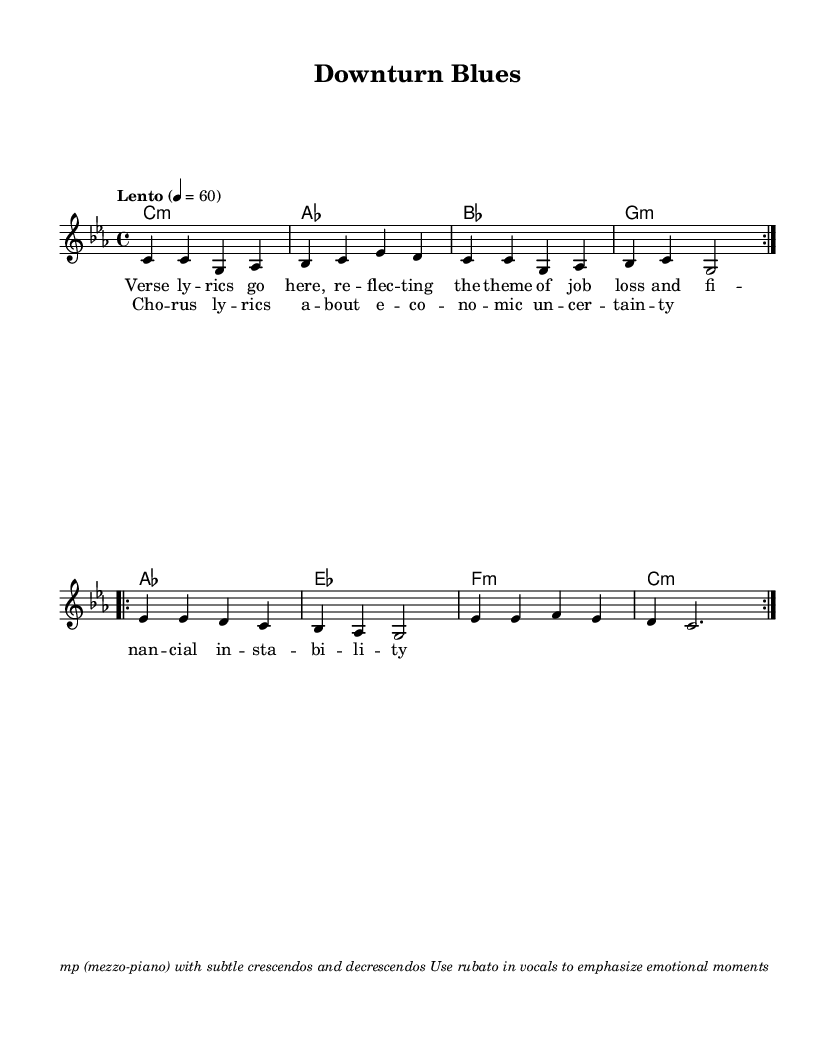What is the key signature of this music? The key signature is C minor, indicated by the presence of three flats in the key signature.
Answer: C minor What is the time signature of this music? The time signature is 4/4, which is noted at the beginning of the score following the key signature.
Answer: 4/4 What is the tempo marking for this piece? The tempo marking is "Lento," which means a slow and broad pace; it indicates 60 beats per minute.
Answer: Lento How many times is the first section repeated? The first section is repeated twice, as indicated by the "repeat volta 2" notation at the beginning of that section.
Answer: Twice What is the emotion conveyed in the lyrics? The lyrics reflect themes of job loss and financial instability, giving rise to a melancholic atmosphere throughout the piece.
Answer: Melancholic What type of harmonic progression is used in the chorus? The chorus utilizes a common pop harmonic progression, featuring a blend of major and minor chords to enhance the emotional impact.
Answer: Major and minor chords What performance technique is suggested for the vocals? The score suggests using rubato in the vocals, which allows for expressive timing variations to emphasize emotional moments.
Answer: Rubato 